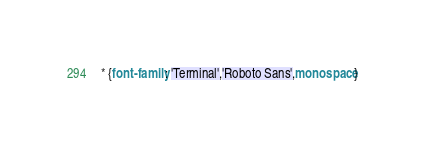<code> <loc_0><loc_0><loc_500><loc_500><_CSS_>* {font-family: 'Terminal','Roboto Sans',monospace}</code> 